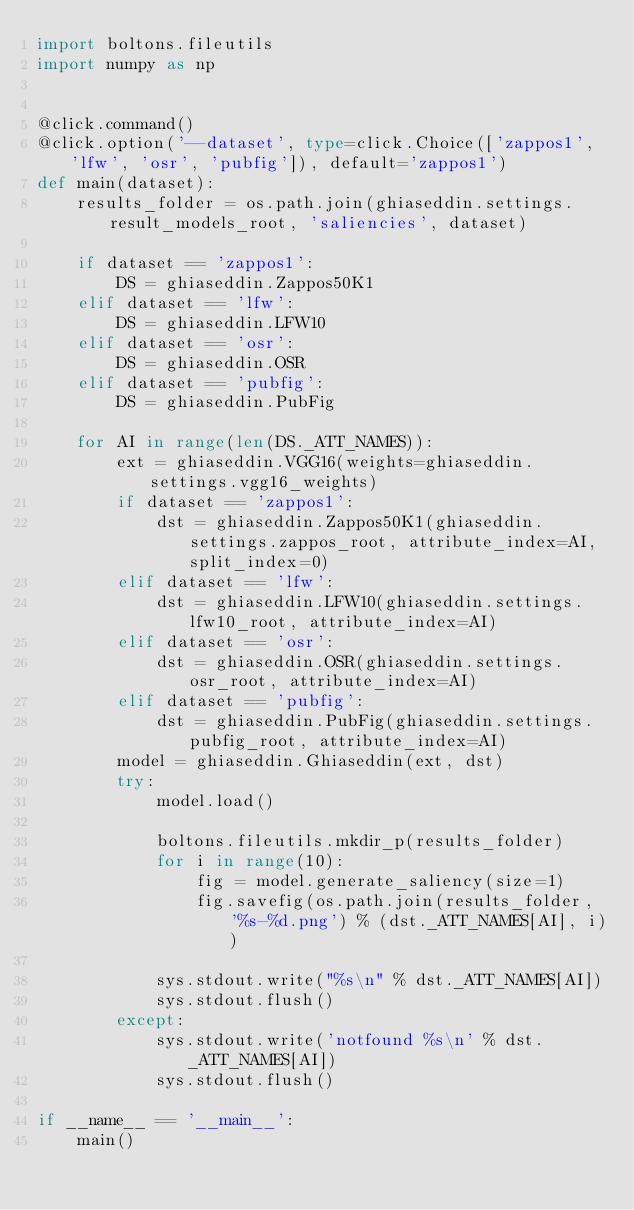<code> <loc_0><loc_0><loc_500><loc_500><_Python_>import boltons.fileutils
import numpy as np


@click.command()
@click.option('--dataset', type=click.Choice(['zappos1', 'lfw', 'osr', 'pubfig']), default='zappos1')
def main(dataset):
    results_folder = os.path.join(ghiaseddin.settings.result_models_root, 'saliencies', dataset)

    if dataset == 'zappos1':
        DS = ghiaseddin.Zappos50K1
    elif dataset == 'lfw':
        DS = ghiaseddin.LFW10
    elif dataset == 'osr':
        DS = ghiaseddin.OSR
    elif dataset == 'pubfig':
        DS = ghiaseddin.PubFig

    for AI in range(len(DS._ATT_NAMES)):
        ext = ghiaseddin.VGG16(weights=ghiaseddin.settings.vgg16_weights)
        if dataset == 'zappos1':
            dst = ghiaseddin.Zappos50K1(ghiaseddin.settings.zappos_root, attribute_index=AI, split_index=0)
        elif dataset == 'lfw':
            dst = ghiaseddin.LFW10(ghiaseddin.settings.lfw10_root, attribute_index=AI)
        elif dataset == 'osr':
            dst = ghiaseddin.OSR(ghiaseddin.settings.osr_root, attribute_index=AI)
        elif dataset == 'pubfig':
            dst = ghiaseddin.PubFig(ghiaseddin.settings.pubfig_root, attribute_index=AI)
        model = ghiaseddin.Ghiaseddin(ext, dst)
        try:
            model.load()
            
            boltons.fileutils.mkdir_p(results_folder)
            for i in range(10):
                fig = model.generate_saliency(size=1)
                fig.savefig(os.path.join(results_folder, '%s-%d.png') % (dst._ATT_NAMES[AI], i))

            sys.stdout.write("%s\n" % dst._ATT_NAMES[AI])
            sys.stdout.flush()
        except:
            sys.stdout.write('notfound %s\n' % dst._ATT_NAMES[AI])
            sys.stdout.flush()

if __name__ == '__main__':
    main()
</code> 